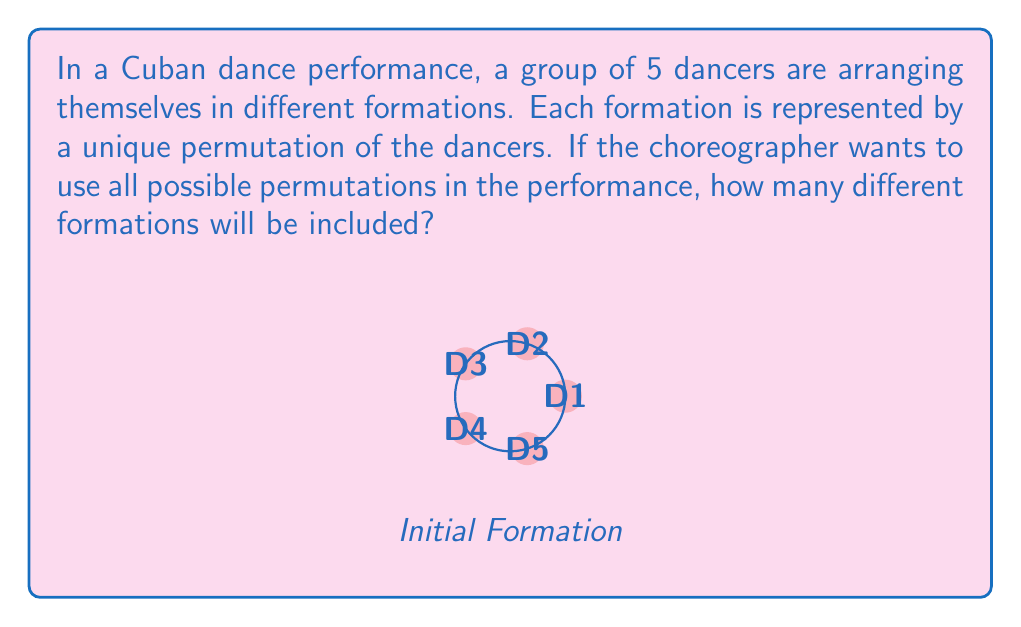Solve this math problem. To solve this problem, we need to calculate the order of the permutation group for 5 dancers. This is equivalent to finding the number of ways to arrange 5 distinct objects, which is given by the factorial of 5.

Step 1: Identify the number of dancers
Number of dancers = 5

Step 2: Recall the formula for permutations
For n distinct objects, the number of permutations is n!

Step 3: Calculate 5!
$$5! = 5 \times 4 \times 3 \times 2 \times 1 = 120$$

Therefore, there are 120 different possible formations that the choreographer can use in the performance. This represents all possible ways to arrange the 5 dancers, where each arrangement is considered a unique formation.

In group theory terms, this means that the order of the symmetric group $S_5$ (which is the permutation group on 5 elements) is 120.
Answer: 120 